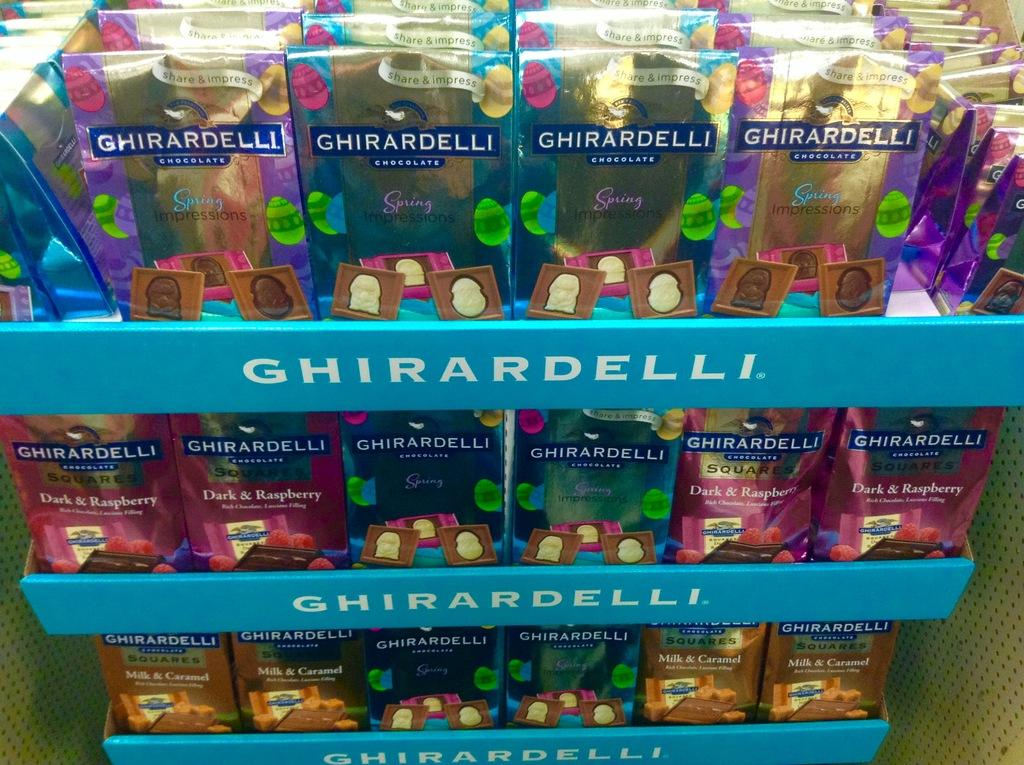<image>
Relay a brief, clear account of the picture shown. Display of Ghirardelli candy and cookies in a store. 